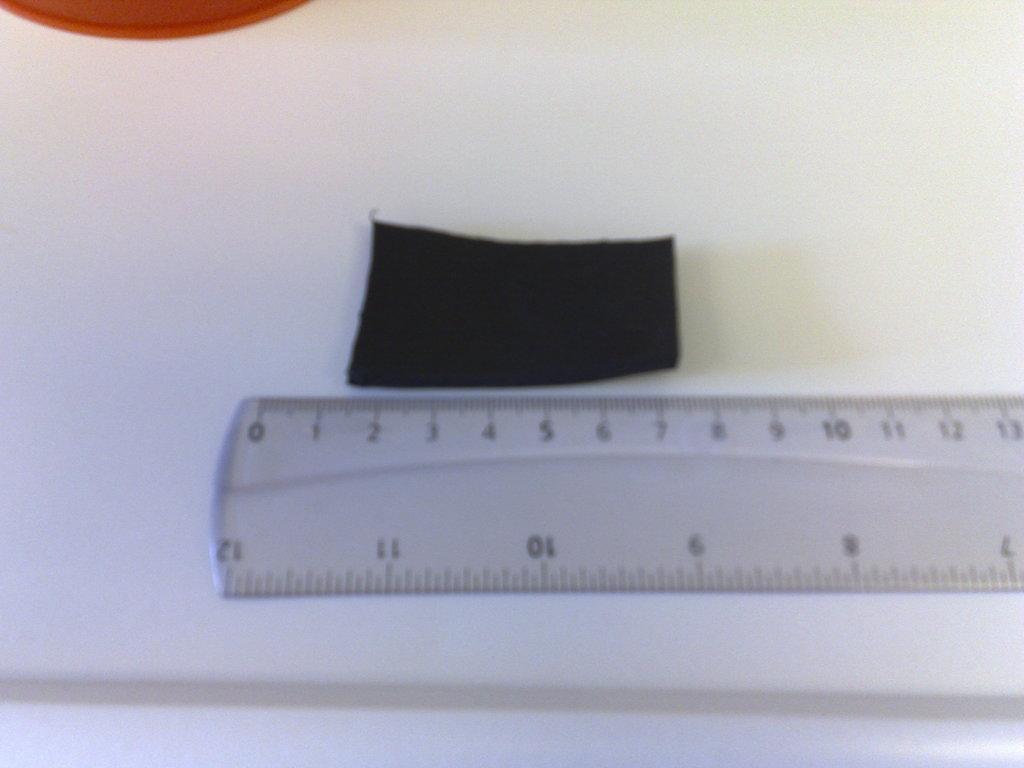Describe this image in one or two sentences. This is a zoomed in picture. In the center we can see a ruler and there are some items placed on a white color object seems to be a paper. 